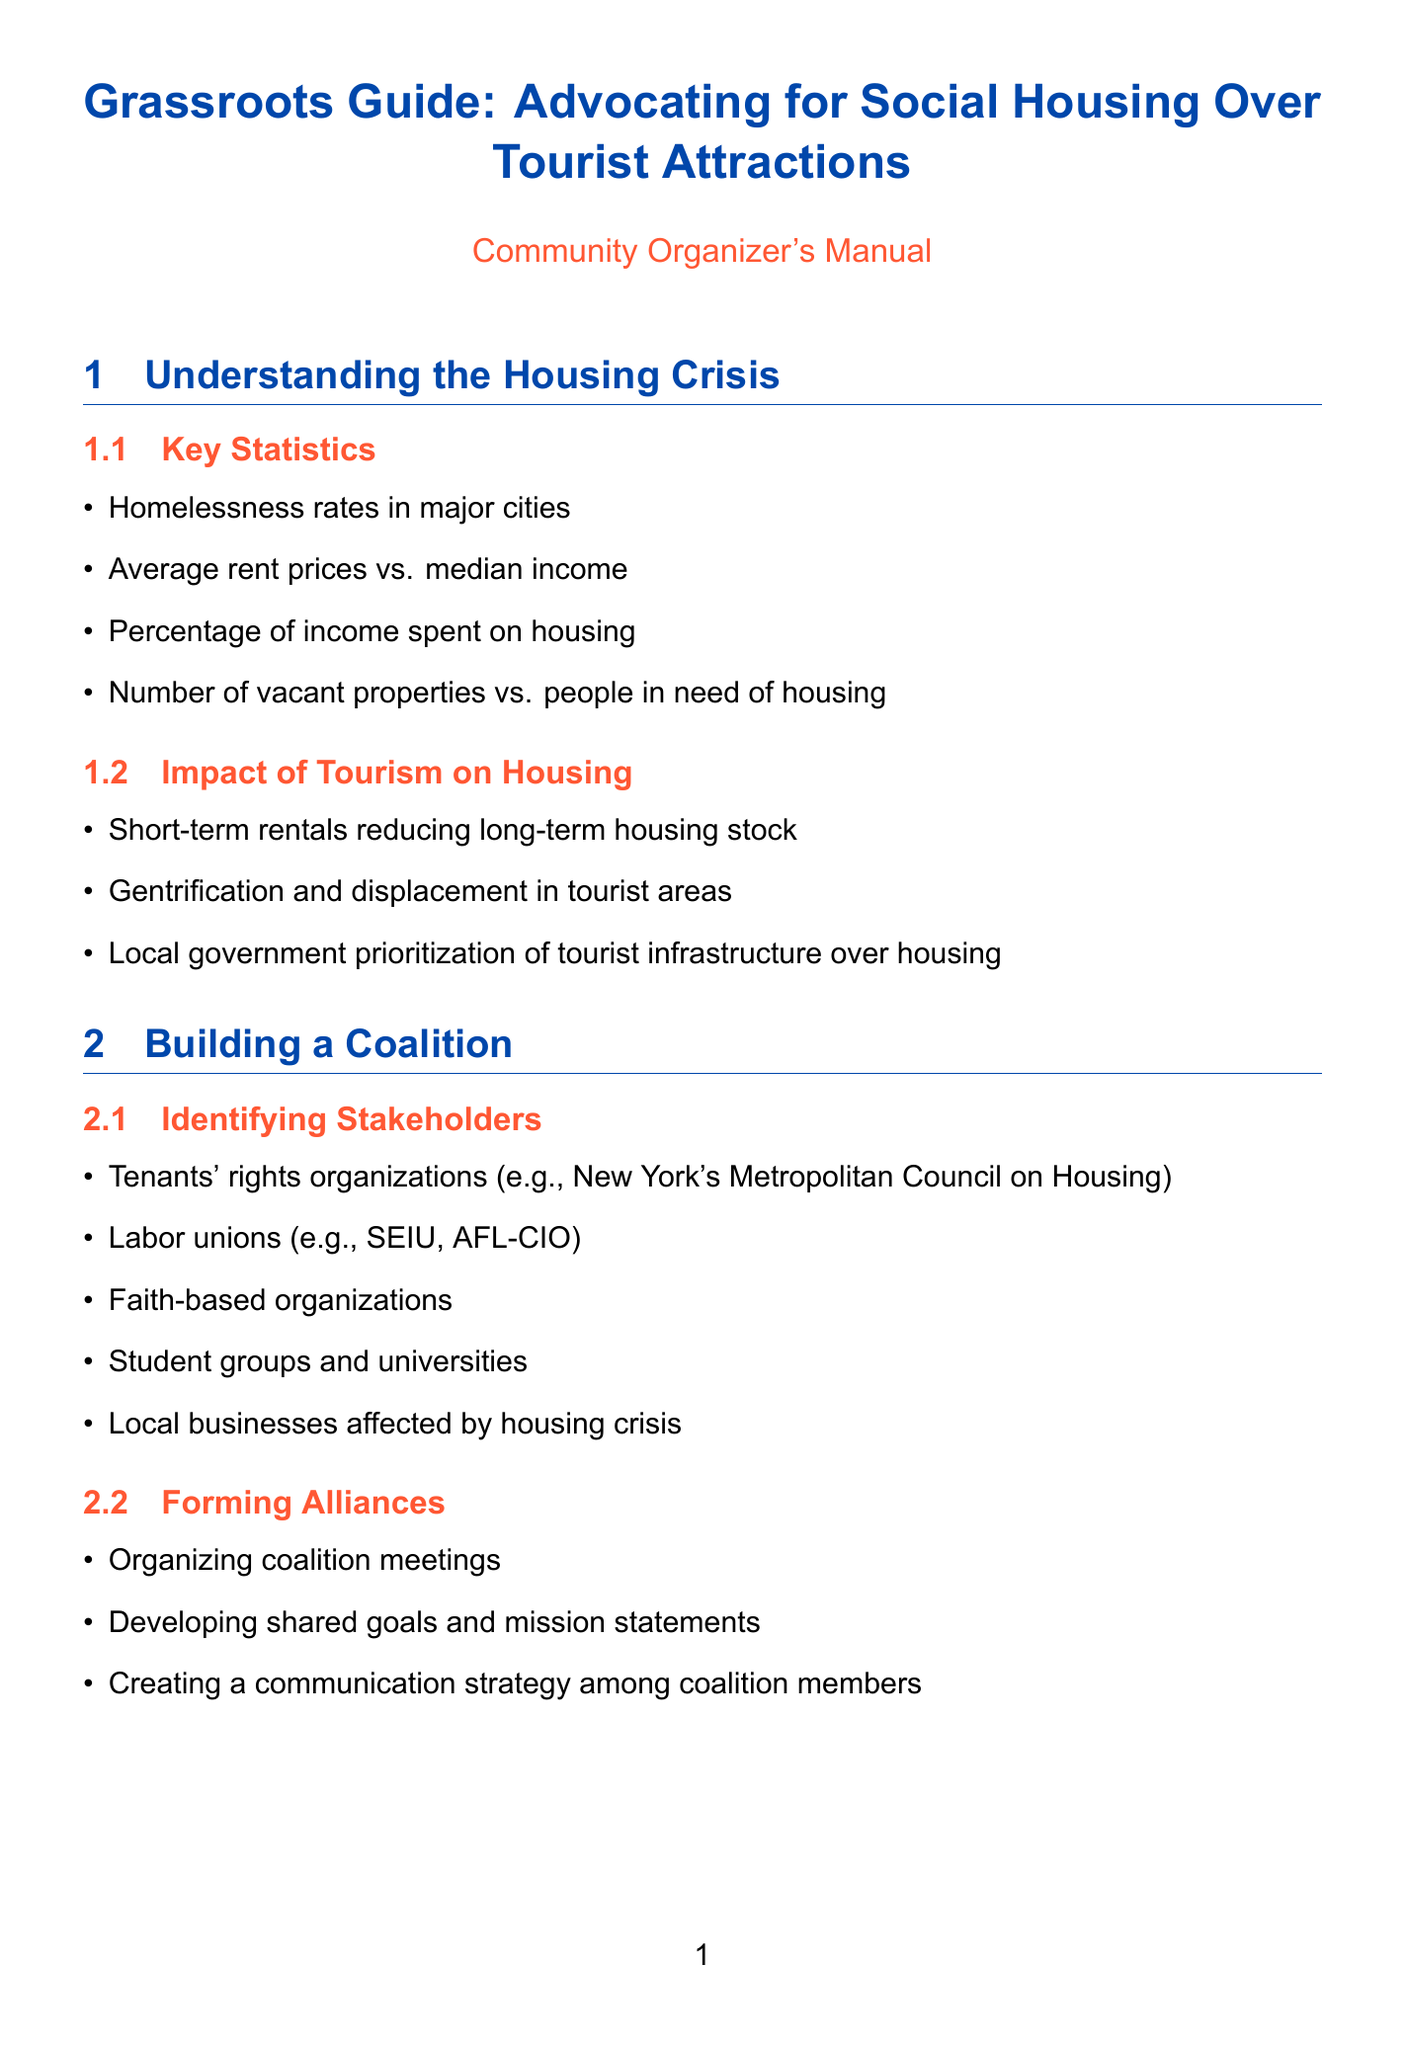What is the title of the manual? The title is clearly stated at the top of the document.
Answer: Grassroots Guide: Advocating for Social Housing Over Tourist Attractions What are some examples of stakeholders in building a coalition? The document lists specific types of stakeholders involved in coalition-building.
Answer: Tenants' rights organizations, labor unions, faith-based organizations, student groups, local businesses What are the tactics mentioned for developing a campaign strategy? The document provides various strategies that can be utilized for advocacy.
Answer: Public demonstrations and rallies, petition drives, town hall meetings, social media campaigns What is one of the fundraising methods outlined in the manual? The document includes various funding strategies relevant to community organizing.
Answer: Grant writing for foundations Which housing model is mentioned as a case study? The manual lists examples of successful housing models used in the past.
Answer: Vienna's social housing model How many evaluation metrics are listed in the document? The section on evaluation metrics specifies what indicators to measure the impact.
Answer: Three What is a key message to craft for media outreach? The manual highlights crucial elements for crafting a compelling message.
Answer: Housing as a human right Who should be identified as key decision makers? The document provides a list of individuals or groups crucial for influencing housing policies.
Answer: City council members What is one technique for lobbying mentioned? The manual suggests specific approaches for effectively lobbying local governments.
Answer: Scheduling face-to-face meetings 